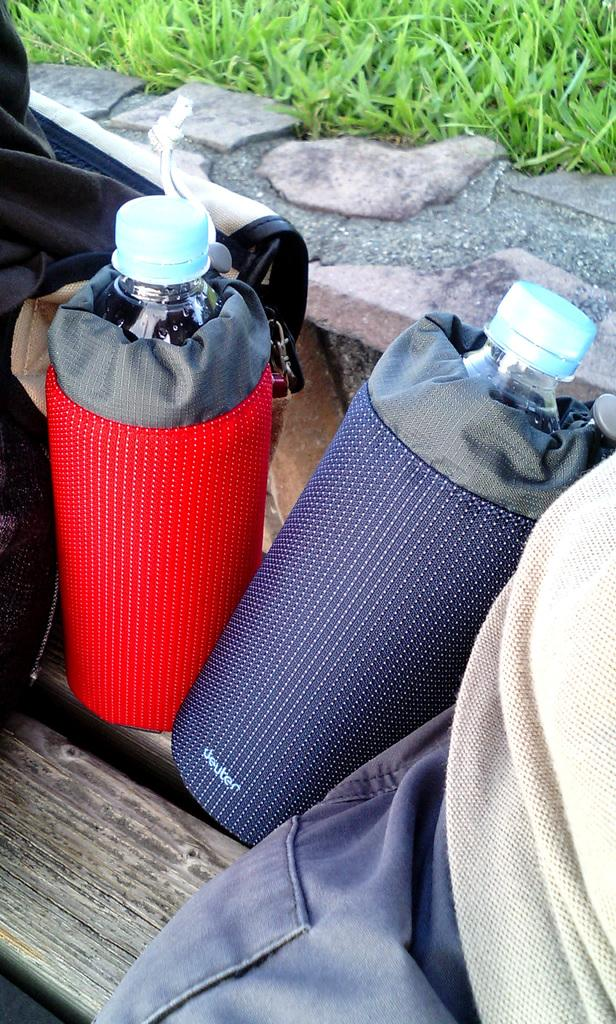What type of surface is visible on the ground in the image? There is grass on the ground in the image. Where are the water bottles located in the image? The water bottles are on a bench in the image. What type of whip can be seen in the image? There is no whip present in the image. How many toothbrushes are visible in the image? There are no toothbrushes visible in the image. 